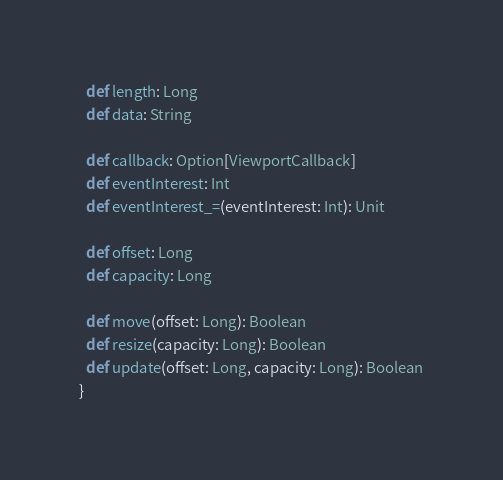Convert code to text. <code><loc_0><loc_0><loc_500><loc_500><_Scala_>  def length: Long
  def data: String

  def callback: Option[ViewportCallback]
  def eventInterest: Int
  def eventInterest_=(eventInterest: Int): Unit

  def offset: Long
  def capacity: Long

  def move(offset: Long): Boolean
  def resize(capacity: Long): Boolean
  def update(offset: Long, capacity: Long): Boolean
}
</code> 